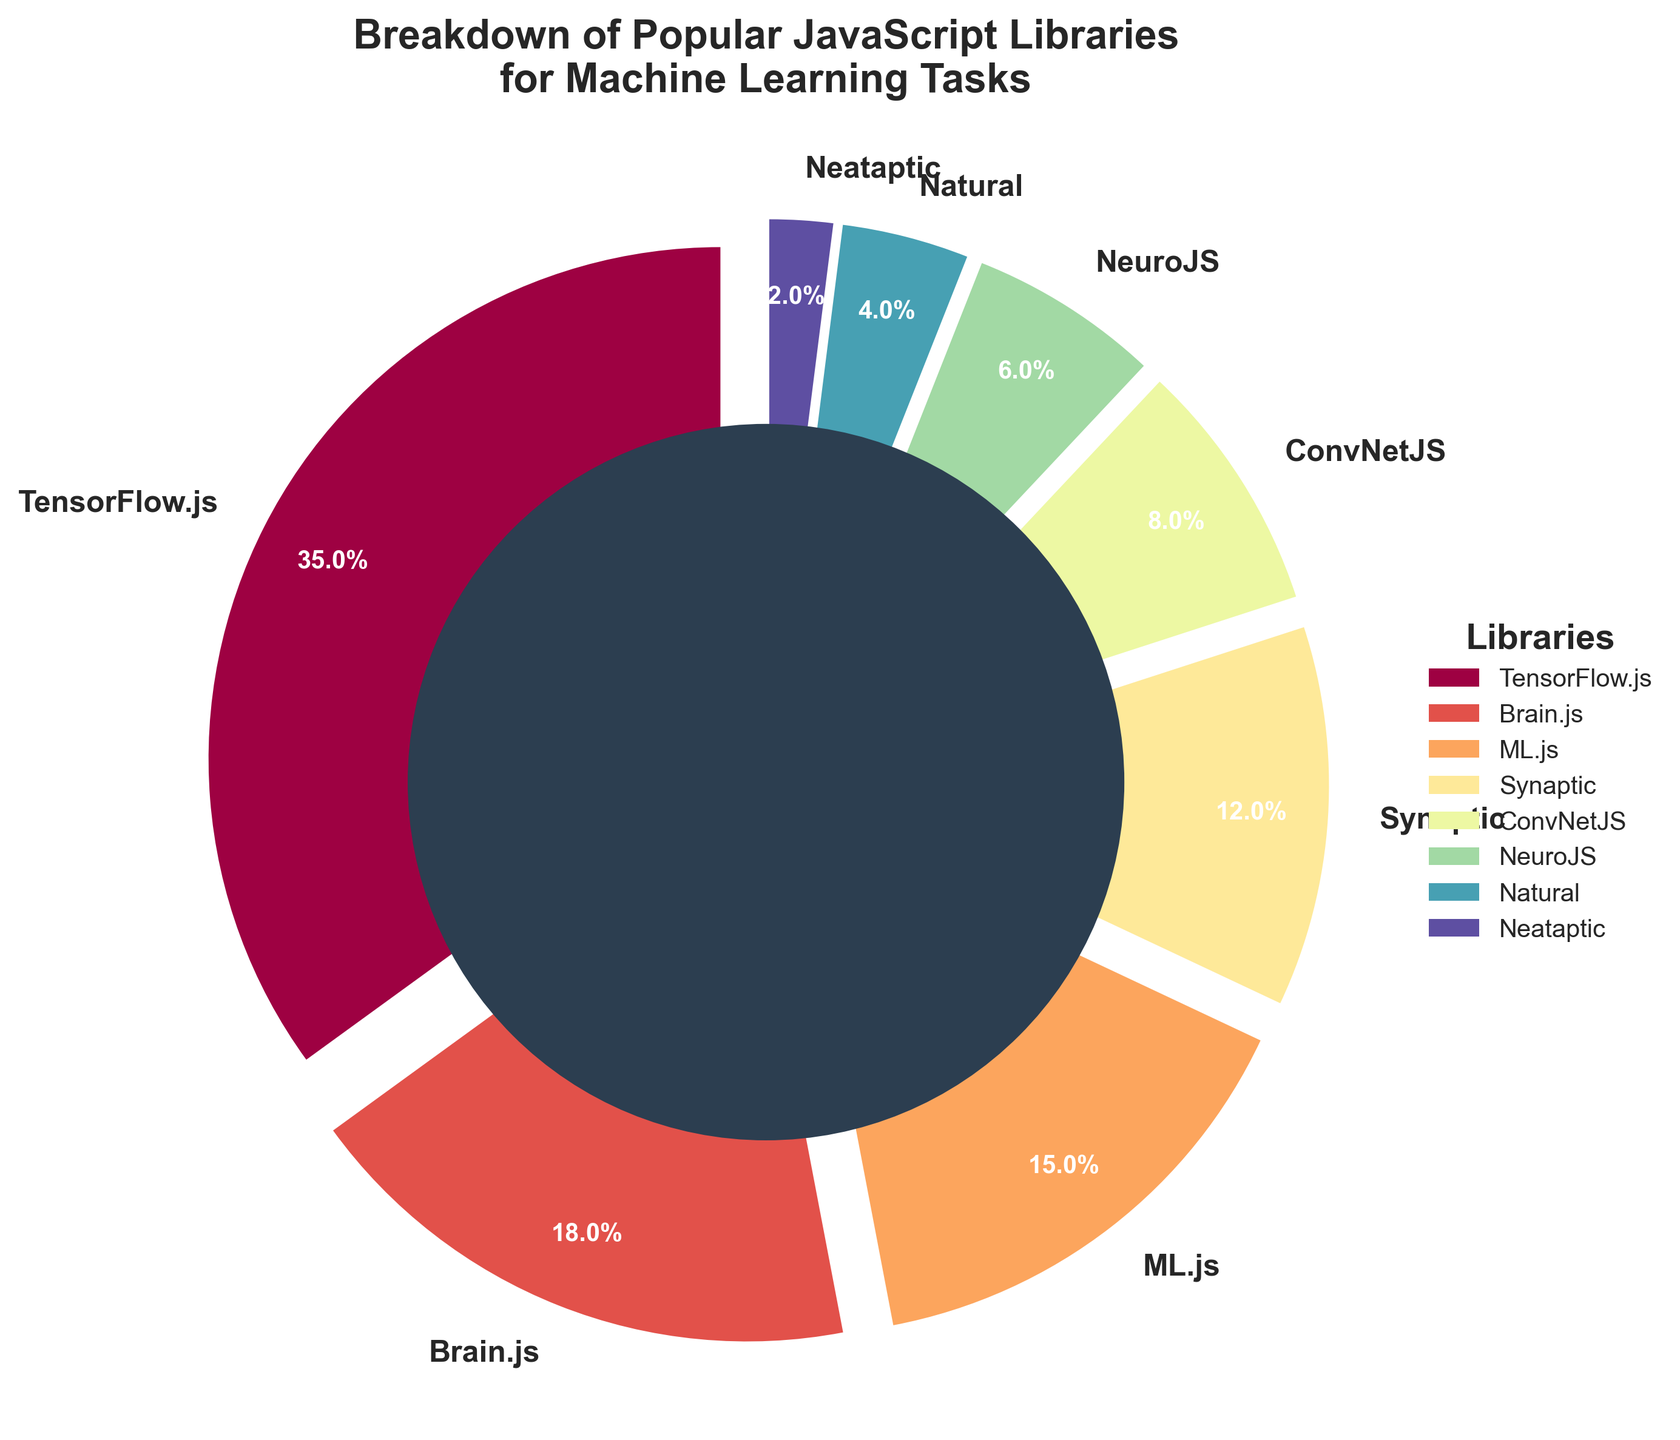What's the most popular JavaScript library for machine learning tasks? Based on the pie chart, the largest segment represents TensorFlow.js, which occupies 35% of the total.
Answer: TensorFlow.js Which two libraries have a combined percentage equal to that of TensorFlow.js? Adding the percentages of Brain.js (18%) and ML.js (15%) gives 18% + 15% = 33%, which does not match 35%. However, adding Brain.js (18%) and Synaptic (12%) sums to 18% + 12% = 30%, which still does not match. No two libraries combine to exactly 35%.
Answer: None How much larger is the percentage of TensorFlow.js compared to Synaptic? TensorFlow.js has 35%, and Synaptic has 12%. The difference is 35% - 12% = 23%.
Answer: 23% What is the total percentage for the bottom three libraries? Summing the percentages of NeuroJS (6%), Natural (4%), and Neataptic (2%) gives 6% + 4% + 2% = 12%.
Answer: 12% Are there more libraries with a percentage greater than 10% or less than 10%? Libraries greater than 10%: TensorFlow.js, Brain.js, ML.js, Synaptic (4 libraries). Libraries less than 10%: ConvNetJS, NeuroJS, Natural, Neataptic (4 libraries). Therefore, both categories have an equal number.
Answer: Equal Which library has the smallest percentage? The smallest segment in the pie chart represents Neataptic at 2%.
Answer: Neataptic If you combine the percentages of Synaptic and ConvNetJS, do they surpass TensorFlow.js? Summing the percentages of Synaptic (12%) and ConvNetJS (8%) gives 12% + 8% = 20%, which is still less than TensorFlow.js's 35%.
Answer: No What's the average percentage of the libraries that have less than 10% share? Summing percentages of ConvNetJS (8%), NeuroJS (6%), Natural (4%), Neataptic (2%) gives 8% + 6% + 4% + 2% = 20%. There are 4 libraries. The average is 20% / 4 = 5%.
Answer: 5% 